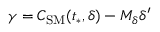Convert formula to latex. <formula><loc_0><loc_0><loc_500><loc_500>\gamma = C _ { S M } ( t _ { * } , \delta ) - M _ { \delta } \delta ^ { \prime }</formula> 